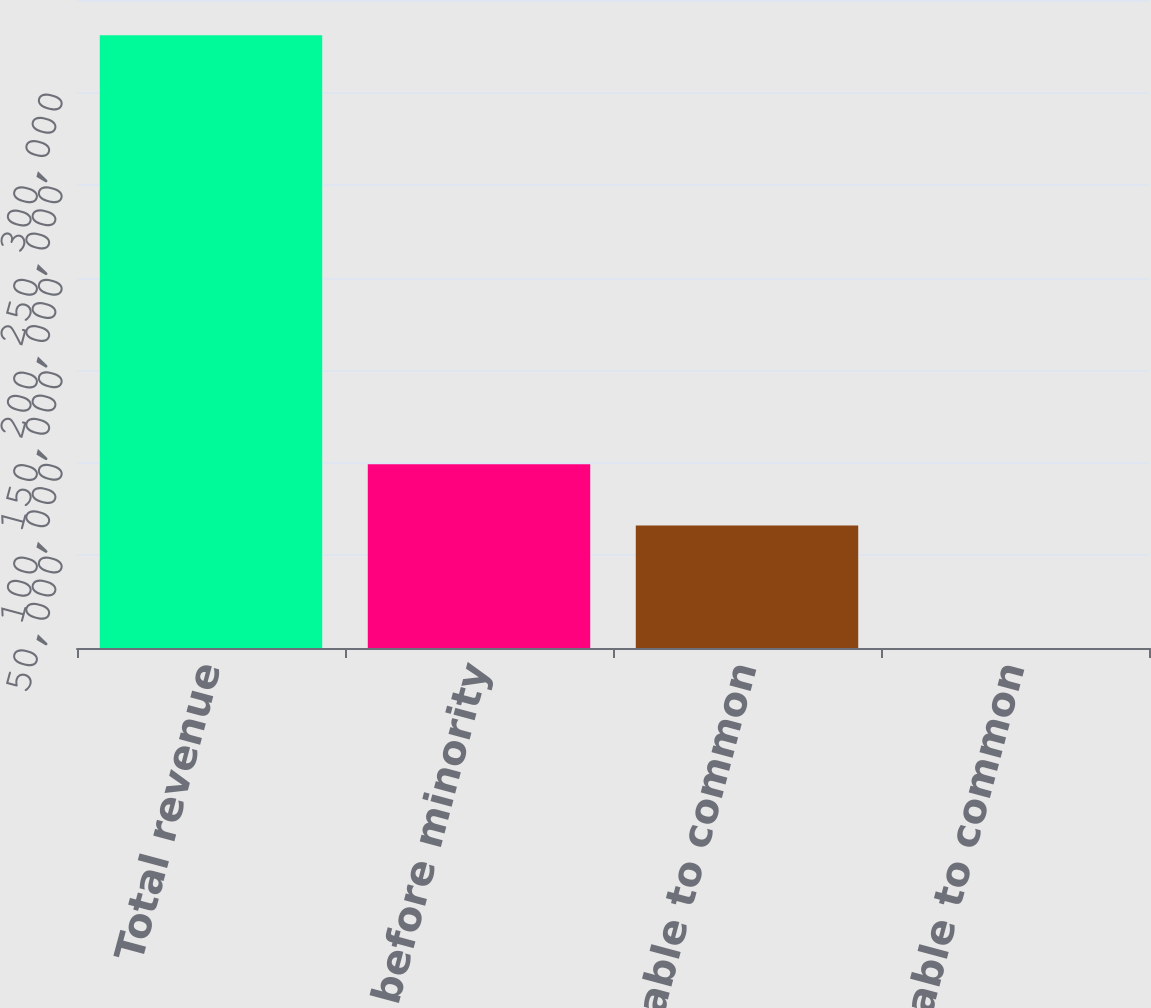Convert chart. <chart><loc_0><loc_0><loc_500><loc_500><bar_chart><fcel>Total revenue<fcel>Income before minority<fcel>Net income available to common<fcel>Income available to common<nl><fcel>330905<fcel>99271.9<fcel>66181.4<fcel>0.57<nl></chart> 